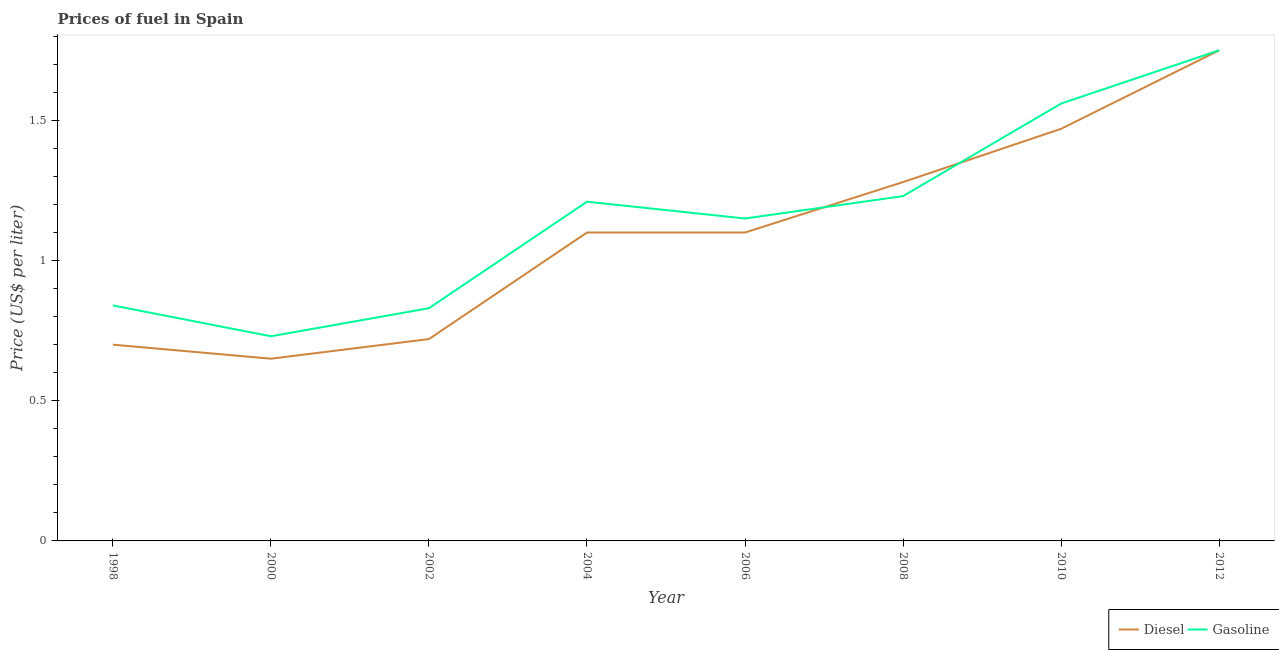How many different coloured lines are there?
Make the answer very short. 2. Is the number of lines equal to the number of legend labels?
Ensure brevity in your answer.  Yes. What is the diesel price in 2008?
Your answer should be compact. 1.28. Across all years, what is the minimum diesel price?
Your answer should be compact. 0.65. In which year was the gasoline price maximum?
Keep it short and to the point. 2012. What is the total diesel price in the graph?
Provide a short and direct response. 8.77. What is the difference between the gasoline price in 1998 and that in 2006?
Give a very brief answer. -0.31. What is the difference between the diesel price in 2004 and the gasoline price in 2002?
Offer a terse response. 0.27. What is the average gasoline price per year?
Your response must be concise. 1.16. In the year 2008, what is the difference between the diesel price and gasoline price?
Provide a succinct answer. 0.05. What is the ratio of the gasoline price in 2000 to that in 2012?
Provide a succinct answer. 0.42. Is the diesel price in 2006 less than that in 2012?
Ensure brevity in your answer.  Yes. Is the difference between the diesel price in 2006 and 2008 greater than the difference between the gasoline price in 2006 and 2008?
Offer a very short reply. No. What is the difference between the highest and the second highest gasoline price?
Offer a terse response. 0.19. What is the difference between the highest and the lowest gasoline price?
Your answer should be very brief. 1.02. In how many years, is the diesel price greater than the average diesel price taken over all years?
Ensure brevity in your answer.  5. Does the gasoline price monotonically increase over the years?
Keep it short and to the point. No. Is the diesel price strictly less than the gasoline price over the years?
Your answer should be very brief. No. How many lines are there?
Provide a short and direct response. 2. How many years are there in the graph?
Offer a very short reply. 8. Are the values on the major ticks of Y-axis written in scientific E-notation?
Ensure brevity in your answer.  No. Does the graph contain grids?
Your answer should be compact. No. Where does the legend appear in the graph?
Provide a short and direct response. Bottom right. How many legend labels are there?
Your answer should be compact. 2. How are the legend labels stacked?
Keep it short and to the point. Horizontal. What is the title of the graph?
Provide a short and direct response. Prices of fuel in Spain. What is the label or title of the X-axis?
Your answer should be compact. Year. What is the label or title of the Y-axis?
Offer a terse response. Price (US$ per liter). What is the Price (US$ per liter) of Diesel in 1998?
Make the answer very short. 0.7. What is the Price (US$ per liter) of Gasoline in 1998?
Give a very brief answer. 0.84. What is the Price (US$ per liter) of Diesel in 2000?
Your answer should be very brief. 0.65. What is the Price (US$ per liter) in Gasoline in 2000?
Your answer should be very brief. 0.73. What is the Price (US$ per liter) of Diesel in 2002?
Provide a short and direct response. 0.72. What is the Price (US$ per liter) of Gasoline in 2002?
Keep it short and to the point. 0.83. What is the Price (US$ per liter) in Diesel in 2004?
Your response must be concise. 1.1. What is the Price (US$ per liter) of Gasoline in 2004?
Offer a terse response. 1.21. What is the Price (US$ per liter) of Gasoline in 2006?
Give a very brief answer. 1.15. What is the Price (US$ per liter) in Diesel in 2008?
Provide a short and direct response. 1.28. What is the Price (US$ per liter) in Gasoline in 2008?
Keep it short and to the point. 1.23. What is the Price (US$ per liter) of Diesel in 2010?
Your answer should be very brief. 1.47. What is the Price (US$ per liter) of Gasoline in 2010?
Your answer should be very brief. 1.56. What is the Price (US$ per liter) in Diesel in 2012?
Ensure brevity in your answer.  1.75. Across all years, what is the maximum Price (US$ per liter) of Diesel?
Give a very brief answer. 1.75. Across all years, what is the maximum Price (US$ per liter) of Gasoline?
Ensure brevity in your answer.  1.75. Across all years, what is the minimum Price (US$ per liter) of Diesel?
Your answer should be compact. 0.65. Across all years, what is the minimum Price (US$ per liter) of Gasoline?
Offer a very short reply. 0.73. What is the total Price (US$ per liter) of Diesel in the graph?
Ensure brevity in your answer.  8.77. What is the difference between the Price (US$ per liter) of Gasoline in 1998 and that in 2000?
Provide a succinct answer. 0.11. What is the difference between the Price (US$ per liter) in Diesel in 1998 and that in 2002?
Your answer should be very brief. -0.02. What is the difference between the Price (US$ per liter) of Diesel in 1998 and that in 2004?
Provide a succinct answer. -0.4. What is the difference between the Price (US$ per liter) of Gasoline in 1998 and that in 2004?
Your answer should be very brief. -0.37. What is the difference between the Price (US$ per liter) of Gasoline in 1998 and that in 2006?
Keep it short and to the point. -0.31. What is the difference between the Price (US$ per liter) in Diesel in 1998 and that in 2008?
Give a very brief answer. -0.58. What is the difference between the Price (US$ per liter) in Gasoline in 1998 and that in 2008?
Your response must be concise. -0.39. What is the difference between the Price (US$ per liter) in Diesel in 1998 and that in 2010?
Offer a very short reply. -0.77. What is the difference between the Price (US$ per liter) in Gasoline in 1998 and that in 2010?
Provide a succinct answer. -0.72. What is the difference between the Price (US$ per liter) in Diesel in 1998 and that in 2012?
Offer a terse response. -1.05. What is the difference between the Price (US$ per liter) in Gasoline in 1998 and that in 2012?
Make the answer very short. -0.91. What is the difference between the Price (US$ per liter) of Diesel in 2000 and that in 2002?
Your response must be concise. -0.07. What is the difference between the Price (US$ per liter) in Gasoline in 2000 and that in 2002?
Offer a terse response. -0.1. What is the difference between the Price (US$ per liter) in Diesel in 2000 and that in 2004?
Ensure brevity in your answer.  -0.45. What is the difference between the Price (US$ per liter) in Gasoline in 2000 and that in 2004?
Keep it short and to the point. -0.48. What is the difference between the Price (US$ per liter) in Diesel in 2000 and that in 2006?
Provide a succinct answer. -0.45. What is the difference between the Price (US$ per liter) of Gasoline in 2000 and that in 2006?
Make the answer very short. -0.42. What is the difference between the Price (US$ per liter) in Diesel in 2000 and that in 2008?
Offer a terse response. -0.63. What is the difference between the Price (US$ per liter) in Gasoline in 2000 and that in 2008?
Give a very brief answer. -0.5. What is the difference between the Price (US$ per liter) in Diesel in 2000 and that in 2010?
Ensure brevity in your answer.  -0.82. What is the difference between the Price (US$ per liter) in Gasoline in 2000 and that in 2010?
Your response must be concise. -0.83. What is the difference between the Price (US$ per liter) of Gasoline in 2000 and that in 2012?
Provide a succinct answer. -1.02. What is the difference between the Price (US$ per liter) of Diesel in 2002 and that in 2004?
Provide a succinct answer. -0.38. What is the difference between the Price (US$ per liter) of Gasoline in 2002 and that in 2004?
Make the answer very short. -0.38. What is the difference between the Price (US$ per liter) of Diesel in 2002 and that in 2006?
Give a very brief answer. -0.38. What is the difference between the Price (US$ per liter) of Gasoline in 2002 and that in 2006?
Your response must be concise. -0.32. What is the difference between the Price (US$ per liter) in Diesel in 2002 and that in 2008?
Your answer should be very brief. -0.56. What is the difference between the Price (US$ per liter) of Diesel in 2002 and that in 2010?
Offer a terse response. -0.75. What is the difference between the Price (US$ per liter) of Gasoline in 2002 and that in 2010?
Your response must be concise. -0.73. What is the difference between the Price (US$ per liter) of Diesel in 2002 and that in 2012?
Make the answer very short. -1.03. What is the difference between the Price (US$ per liter) in Gasoline in 2002 and that in 2012?
Your answer should be compact. -0.92. What is the difference between the Price (US$ per liter) of Gasoline in 2004 and that in 2006?
Your response must be concise. 0.06. What is the difference between the Price (US$ per liter) of Diesel in 2004 and that in 2008?
Your response must be concise. -0.18. What is the difference between the Price (US$ per liter) of Gasoline in 2004 and that in 2008?
Your answer should be very brief. -0.02. What is the difference between the Price (US$ per liter) in Diesel in 2004 and that in 2010?
Provide a short and direct response. -0.37. What is the difference between the Price (US$ per liter) of Gasoline in 2004 and that in 2010?
Your answer should be compact. -0.35. What is the difference between the Price (US$ per liter) of Diesel in 2004 and that in 2012?
Your answer should be compact. -0.65. What is the difference between the Price (US$ per liter) of Gasoline in 2004 and that in 2012?
Provide a short and direct response. -0.54. What is the difference between the Price (US$ per liter) of Diesel in 2006 and that in 2008?
Offer a very short reply. -0.18. What is the difference between the Price (US$ per liter) of Gasoline in 2006 and that in 2008?
Offer a terse response. -0.08. What is the difference between the Price (US$ per liter) in Diesel in 2006 and that in 2010?
Your answer should be very brief. -0.37. What is the difference between the Price (US$ per liter) in Gasoline in 2006 and that in 2010?
Your answer should be very brief. -0.41. What is the difference between the Price (US$ per liter) of Diesel in 2006 and that in 2012?
Give a very brief answer. -0.65. What is the difference between the Price (US$ per liter) in Diesel in 2008 and that in 2010?
Your response must be concise. -0.19. What is the difference between the Price (US$ per liter) of Gasoline in 2008 and that in 2010?
Make the answer very short. -0.33. What is the difference between the Price (US$ per liter) of Diesel in 2008 and that in 2012?
Your response must be concise. -0.47. What is the difference between the Price (US$ per liter) of Gasoline in 2008 and that in 2012?
Keep it short and to the point. -0.52. What is the difference between the Price (US$ per liter) of Diesel in 2010 and that in 2012?
Your answer should be compact. -0.28. What is the difference between the Price (US$ per liter) of Gasoline in 2010 and that in 2012?
Your answer should be compact. -0.19. What is the difference between the Price (US$ per liter) of Diesel in 1998 and the Price (US$ per liter) of Gasoline in 2000?
Provide a succinct answer. -0.03. What is the difference between the Price (US$ per liter) in Diesel in 1998 and the Price (US$ per liter) in Gasoline in 2002?
Offer a very short reply. -0.13. What is the difference between the Price (US$ per liter) in Diesel in 1998 and the Price (US$ per liter) in Gasoline in 2004?
Offer a very short reply. -0.51. What is the difference between the Price (US$ per liter) in Diesel in 1998 and the Price (US$ per liter) in Gasoline in 2006?
Provide a succinct answer. -0.45. What is the difference between the Price (US$ per liter) of Diesel in 1998 and the Price (US$ per liter) of Gasoline in 2008?
Your answer should be compact. -0.53. What is the difference between the Price (US$ per liter) of Diesel in 1998 and the Price (US$ per liter) of Gasoline in 2010?
Make the answer very short. -0.86. What is the difference between the Price (US$ per liter) of Diesel in 1998 and the Price (US$ per liter) of Gasoline in 2012?
Your answer should be very brief. -1.05. What is the difference between the Price (US$ per liter) in Diesel in 2000 and the Price (US$ per liter) in Gasoline in 2002?
Provide a short and direct response. -0.18. What is the difference between the Price (US$ per liter) of Diesel in 2000 and the Price (US$ per liter) of Gasoline in 2004?
Your response must be concise. -0.56. What is the difference between the Price (US$ per liter) in Diesel in 2000 and the Price (US$ per liter) in Gasoline in 2006?
Offer a terse response. -0.5. What is the difference between the Price (US$ per liter) of Diesel in 2000 and the Price (US$ per liter) of Gasoline in 2008?
Provide a succinct answer. -0.58. What is the difference between the Price (US$ per liter) of Diesel in 2000 and the Price (US$ per liter) of Gasoline in 2010?
Offer a very short reply. -0.91. What is the difference between the Price (US$ per liter) of Diesel in 2000 and the Price (US$ per liter) of Gasoline in 2012?
Make the answer very short. -1.1. What is the difference between the Price (US$ per liter) of Diesel in 2002 and the Price (US$ per liter) of Gasoline in 2004?
Your answer should be very brief. -0.49. What is the difference between the Price (US$ per liter) in Diesel in 2002 and the Price (US$ per liter) in Gasoline in 2006?
Ensure brevity in your answer.  -0.43. What is the difference between the Price (US$ per liter) in Diesel in 2002 and the Price (US$ per liter) in Gasoline in 2008?
Make the answer very short. -0.51. What is the difference between the Price (US$ per liter) of Diesel in 2002 and the Price (US$ per liter) of Gasoline in 2010?
Your response must be concise. -0.84. What is the difference between the Price (US$ per liter) in Diesel in 2002 and the Price (US$ per liter) in Gasoline in 2012?
Provide a short and direct response. -1.03. What is the difference between the Price (US$ per liter) in Diesel in 2004 and the Price (US$ per liter) in Gasoline in 2006?
Keep it short and to the point. -0.05. What is the difference between the Price (US$ per liter) in Diesel in 2004 and the Price (US$ per liter) in Gasoline in 2008?
Make the answer very short. -0.13. What is the difference between the Price (US$ per liter) in Diesel in 2004 and the Price (US$ per liter) in Gasoline in 2010?
Ensure brevity in your answer.  -0.46. What is the difference between the Price (US$ per liter) in Diesel in 2004 and the Price (US$ per liter) in Gasoline in 2012?
Your answer should be very brief. -0.65. What is the difference between the Price (US$ per liter) of Diesel in 2006 and the Price (US$ per liter) of Gasoline in 2008?
Keep it short and to the point. -0.13. What is the difference between the Price (US$ per liter) of Diesel in 2006 and the Price (US$ per liter) of Gasoline in 2010?
Your answer should be compact. -0.46. What is the difference between the Price (US$ per liter) in Diesel in 2006 and the Price (US$ per liter) in Gasoline in 2012?
Your answer should be compact. -0.65. What is the difference between the Price (US$ per liter) of Diesel in 2008 and the Price (US$ per liter) of Gasoline in 2010?
Your answer should be very brief. -0.28. What is the difference between the Price (US$ per liter) of Diesel in 2008 and the Price (US$ per liter) of Gasoline in 2012?
Offer a very short reply. -0.47. What is the difference between the Price (US$ per liter) in Diesel in 2010 and the Price (US$ per liter) in Gasoline in 2012?
Your answer should be very brief. -0.28. What is the average Price (US$ per liter) in Diesel per year?
Keep it short and to the point. 1.1. What is the average Price (US$ per liter) in Gasoline per year?
Provide a succinct answer. 1.16. In the year 1998, what is the difference between the Price (US$ per liter) in Diesel and Price (US$ per liter) in Gasoline?
Your answer should be compact. -0.14. In the year 2000, what is the difference between the Price (US$ per liter) in Diesel and Price (US$ per liter) in Gasoline?
Your answer should be compact. -0.08. In the year 2002, what is the difference between the Price (US$ per liter) in Diesel and Price (US$ per liter) in Gasoline?
Provide a short and direct response. -0.11. In the year 2004, what is the difference between the Price (US$ per liter) of Diesel and Price (US$ per liter) of Gasoline?
Offer a very short reply. -0.11. In the year 2008, what is the difference between the Price (US$ per liter) in Diesel and Price (US$ per liter) in Gasoline?
Your answer should be compact. 0.05. In the year 2010, what is the difference between the Price (US$ per liter) in Diesel and Price (US$ per liter) in Gasoline?
Your response must be concise. -0.09. In the year 2012, what is the difference between the Price (US$ per liter) in Diesel and Price (US$ per liter) in Gasoline?
Your answer should be compact. 0. What is the ratio of the Price (US$ per liter) of Gasoline in 1998 to that in 2000?
Offer a very short reply. 1.15. What is the ratio of the Price (US$ per liter) in Diesel in 1998 to that in 2002?
Your answer should be very brief. 0.97. What is the ratio of the Price (US$ per liter) of Gasoline in 1998 to that in 2002?
Your answer should be very brief. 1.01. What is the ratio of the Price (US$ per liter) in Diesel in 1998 to that in 2004?
Your answer should be very brief. 0.64. What is the ratio of the Price (US$ per liter) in Gasoline in 1998 to that in 2004?
Offer a terse response. 0.69. What is the ratio of the Price (US$ per liter) in Diesel in 1998 to that in 2006?
Your response must be concise. 0.64. What is the ratio of the Price (US$ per liter) in Gasoline in 1998 to that in 2006?
Make the answer very short. 0.73. What is the ratio of the Price (US$ per liter) of Diesel in 1998 to that in 2008?
Ensure brevity in your answer.  0.55. What is the ratio of the Price (US$ per liter) of Gasoline in 1998 to that in 2008?
Offer a very short reply. 0.68. What is the ratio of the Price (US$ per liter) in Diesel in 1998 to that in 2010?
Your response must be concise. 0.48. What is the ratio of the Price (US$ per liter) of Gasoline in 1998 to that in 2010?
Give a very brief answer. 0.54. What is the ratio of the Price (US$ per liter) of Gasoline in 1998 to that in 2012?
Your answer should be very brief. 0.48. What is the ratio of the Price (US$ per liter) of Diesel in 2000 to that in 2002?
Give a very brief answer. 0.9. What is the ratio of the Price (US$ per liter) in Gasoline in 2000 to that in 2002?
Make the answer very short. 0.88. What is the ratio of the Price (US$ per liter) in Diesel in 2000 to that in 2004?
Offer a very short reply. 0.59. What is the ratio of the Price (US$ per liter) of Gasoline in 2000 to that in 2004?
Give a very brief answer. 0.6. What is the ratio of the Price (US$ per liter) in Diesel in 2000 to that in 2006?
Your answer should be compact. 0.59. What is the ratio of the Price (US$ per liter) in Gasoline in 2000 to that in 2006?
Provide a succinct answer. 0.63. What is the ratio of the Price (US$ per liter) in Diesel in 2000 to that in 2008?
Make the answer very short. 0.51. What is the ratio of the Price (US$ per liter) of Gasoline in 2000 to that in 2008?
Provide a short and direct response. 0.59. What is the ratio of the Price (US$ per liter) of Diesel in 2000 to that in 2010?
Your response must be concise. 0.44. What is the ratio of the Price (US$ per liter) of Gasoline in 2000 to that in 2010?
Ensure brevity in your answer.  0.47. What is the ratio of the Price (US$ per liter) in Diesel in 2000 to that in 2012?
Offer a terse response. 0.37. What is the ratio of the Price (US$ per liter) in Gasoline in 2000 to that in 2012?
Make the answer very short. 0.42. What is the ratio of the Price (US$ per liter) of Diesel in 2002 to that in 2004?
Your answer should be compact. 0.65. What is the ratio of the Price (US$ per liter) in Gasoline in 2002 to that in 2004?
Provide a short and direct response. 0.69. What is the ratio of the Price (US$ per liter) in Diesel in 2002 to that in 2006?
Provide a succinct answer. 0.65. What is the ratio of the Price (US$ per liter) in Gasoline in 2002 to that in 2006?
Your response must be concise. 0.72. What is the ratio of the Price (US$ per liter) of Diesel in 2002 to that in 2008?
Your response must be concise. 0.56. What is the ratio of the Price (US$ per liter) in Gasoline in 2002 to that in 2008?
Keep it short and to the point. 0.67. What is the ratio of the Price (US$ per liter) in Diesel in 2002 to that in 2010?
Ensure brevity in your answer.  0.49. What is the ratio of the Price (US$ per liter) of Gasoline in 2002 to that in 2010?
Keep it short and to the point. 0.53. What is the ratio of the Price (US$ per liter) of Diesel in 2002 to that in 2012?
Your answer should be compact. 0.41. What is the ratio of the Price (US$ per liter) of Gasoline in 2002 to that in 2012?
Make the answer very short. 0.47. What is the ratio of the Price (US$ per liter) in Gasoline in 2004 to that in 2006?
Ensure brevity in your answer.  1.05. What is the ratio of the Price (US$ per liter) of Diesel in 2004 to that in 2008?
Provide a succinct answer. 0.86. What is the ratio of the Price (US$ per liter) of Gasoline in 2004 to that in 2008?
Ensure brevity in your answer.  0.98. What is the ratio of the Price (US$ per liter) of Diesel in 2004 to that in 2010?
Offer a very short reply. 0.75. What is the ratio of the Price (US$ per liter) of Gasoline in 2004 to that in 2010?
Your answer should be compact. 0.78. What is the ratio of the Price (US$ per liter) in Diesel in 2004 to that in 2012?
Keep it short and to the point. 0.63. What is the ratio of the Price (US$ per liter) of Gasoline in 2004 to that in 2012?
Provide a short and direct response. 0.69. What is the ratio of the Price (US$ per liter) in Diesel in 2006 to that in 2008?
Offer a terse response. 0.86. What is the ratio of the Price (US$ per liter) in Gasoline in 2006 to that in 2008?
Ensure brevity in your answer.  0.94. What is the ratio of the Price (US$ per liter) in Diesel in 2006 to that in 2010?
Keep it short and to the point. 0.75. What is the ratio of the Price (US$ per liter) of Gasoline in 2006 to that in 2010?
Provide a short and direct response. 0.74. What is the ratio of the Price (US$ per liter) in Diesel in 2006 to that in 2012?
Ensure brevity in your answer.  0.63. What is the ratio of the Price (US$ per liter) of Gasoline in 2006 to that in 2012?
Offer a terse response. 0.66. What is the ratio of the Price (US$ per liter) of Diesel in 2008 to that in 2010?
Keep it short and to the point. 0.87. What is the ratio of the Price (US$ per liter) in Gasoline in 2008 to that in 2010?
Offer a terse response. 0.79. What is the ratio of the Price (US$ per liter) of Diesel in 2008 to that in 2012?
Make the answer very short. 0.73. What is the ratio of the Price (US$ per liter) of Gasoline in 2008 to that in 2012?
Offer a terse response. 0.7. What is the ratio of the Price (US$ per liter) of Diesel in 2010 to that in 2012?
Your answer should be compact. 0.84. What is the ratio of the Price (US$ per liter) of Gasoline in 2010 to that in 2012?
Your answer should be compact. 0.89. What is the difference between the highest and the second highest Price (US$ per liter) in Diesel?
Your answer should be compact. 0.28. What is the difference between the highest and the second highest Price (US$ per liter) in Gasoline?
Make the answer very short. 0.19. 